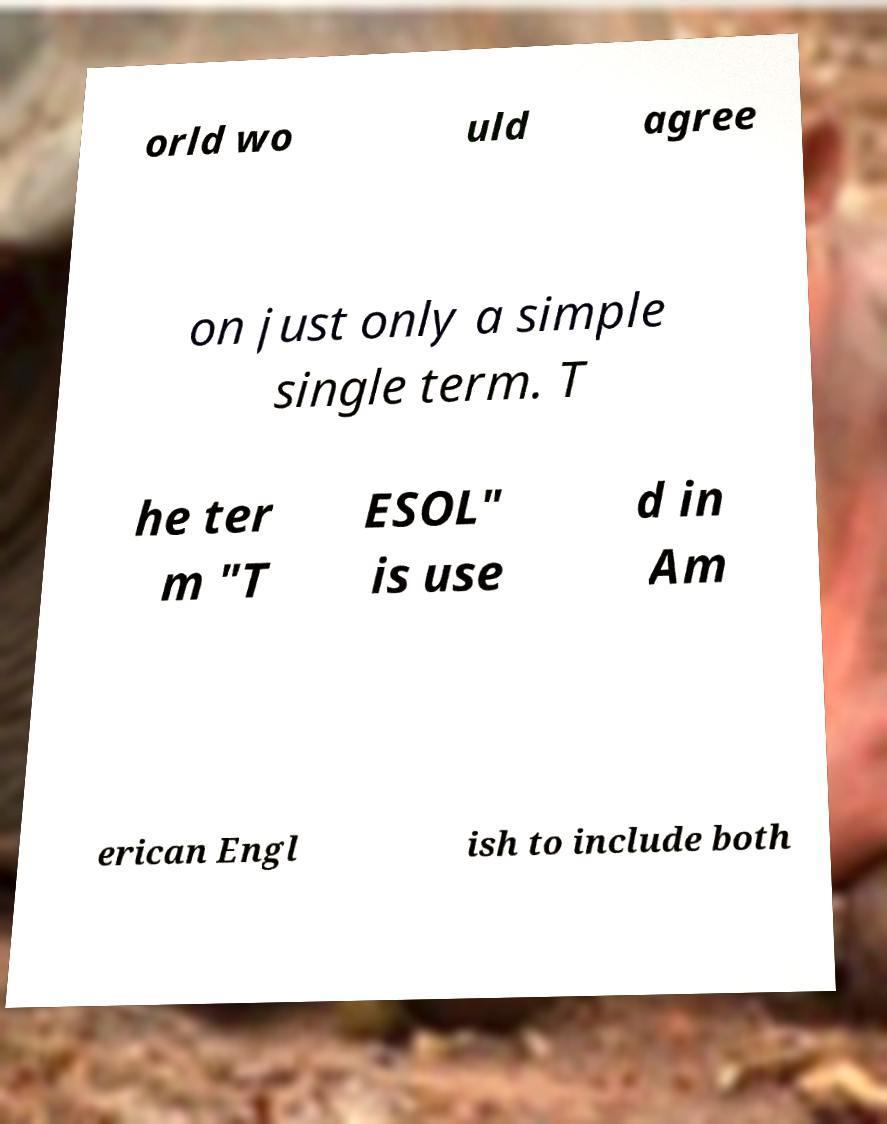What messages or text are displayed in this image? I need them in a readable, typed format. orld wo uld agree on just only a simple single term. T he ter m "T ESOL" is use d in Am erican Engl ish to include both 